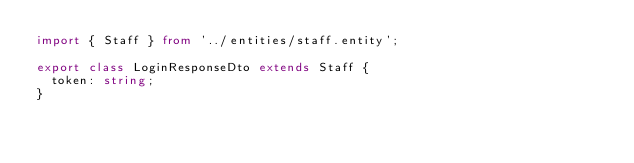<code> <loc_0><loc_0><loc_500><loc_500><_TypeScript_>import { Staff } from '../entities/staff.entity';

export class LoginResponseDto extends Staff {
  token: string;
}
</code> 